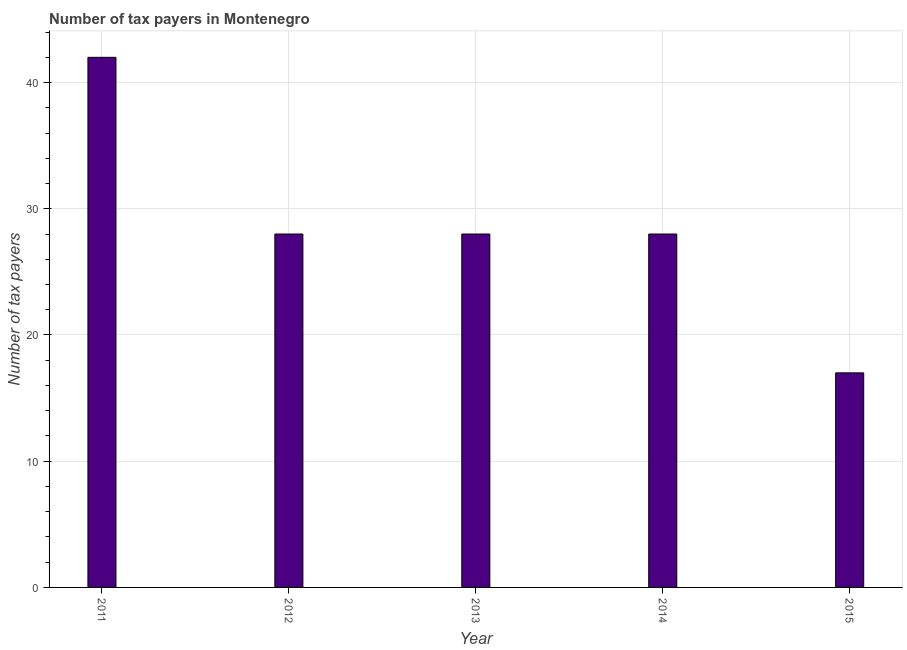What is the title of the graph?
Provide a short and direct response. Number of tax payers in Montenegro. What is the label or title of the X-axis?
Your response must be concise. Year. What is the label or title of the Y-axis?
Offer a terse response. Number of tax payers. What is the number of tax payers in 2015?
Make the answer very short. 17. Across all years, what is the minimum number of tax payers?
Offer a terse response. 17. In which year was the number of tax payers maximum?
Your answer should be compact. 2011. In which year was the number of tax payers minimum?
Your response must be concise. 2015. What is the sum of the number of tax payers?
Provide a short and direct response. 143. What is the difference between the number of tax payers in 2013 and 2015?
Offer a very short reply. 11. What is the average number of tax payers per year?
Give a very brief answer. 28. In how many years, is the number of tax payers greater than 22 ?
Keep it short and to the point. 4. Do a majority of the years between 2015 and 2013 (inclusive) have number of tax payers greater than 32 ?
Your answer should be very brief. Yes. What is the ratio of the number of tax payers in 2014 to that in 2015?
Give a very brief answer. 1.65. What is the difference between the highest and the lowest number of tax payers?
Your answer should be compact. 25. In how many years, is the number of tax payers greater than the average number of tax payers taken over all years?
Provide a short and direct response. 1. How many bars are there?
Provide a short and direct response. 5. What is the difference between two consecutive major ticks on the Y-axis?
Your response must be concise. 10. Are the values on the major ticks of Y-axis written in scientific E-notation?
Keep it short and to the point. No. What is the Number of tax payers of 2015?
Provide a succinct answer. 17. What is the difference between the Number of tax payers in 2011 and 2014?
Offer a very short reply. 14. What is the difference between the Number of tax payers in 2011 and 2015?
Make the answer very short. 25. What is the difference between the Number of tax payers in 2012 and 2014?
Make the answer very short. 0. What is the difference between the Number of tax payers in 2012 and 2015?
Your answer should be compact. 11. What is the difference between the Number of tax payers in 2013 and 2014?
Your response must be concise. 0. What is the difference between the Number of tax payers in 2013 and 2015?
Provide a succinct answer. 11. What is the difference between the Number of tax payers in 2014 and 2015?
Ensure brevity in your answer.  11. What is the ratio of the Number of tax payers in 2011 to that in 2012?
Make the answer very short. 1.5. What is the ratio of the Number of tax payers in 2011 to that in 2015?
Keep it short and to the point. 2.47. What is the ratio of the Number of tax payers in 2012 to that in 2013?
Offer a very short reply. 1. What is the ratio of the Number of tax payers in 2012 to that in 2014?
Your response must be concise. 1. What is the ratio of the Number of tax payers in 2012 to that in 2015?
Provide a short and direct response. 1.65. What is the ratio of the Number of tax payers in 2013 to that in 2014?
Keep it short and to the point. 1. What is the ratio of the Number of tax payers in 2013 to that in 2015?
Your answer should be compact. 1.65. What is the ratio of the Number of tax payers in 2014 to that in 2015?
Give a very brief answer. 1.65. 